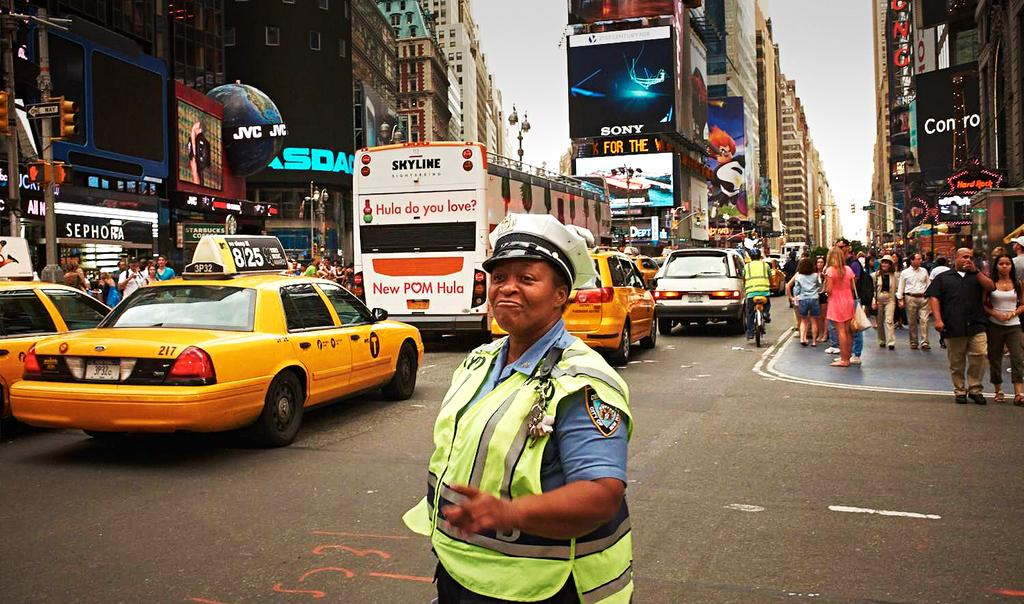<image>
Relay a brief, clear account of the picture shown. A police woman directing traffic on a street with a Sephora, a JVC, a NASDAQ display, and a Sony ad behind her. 